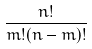Convert formula to latex. <formula><loc_0><loc_0><loc_500><loc_500>\frac { n ! } { m ! ( n - m ) ! }</formula> 